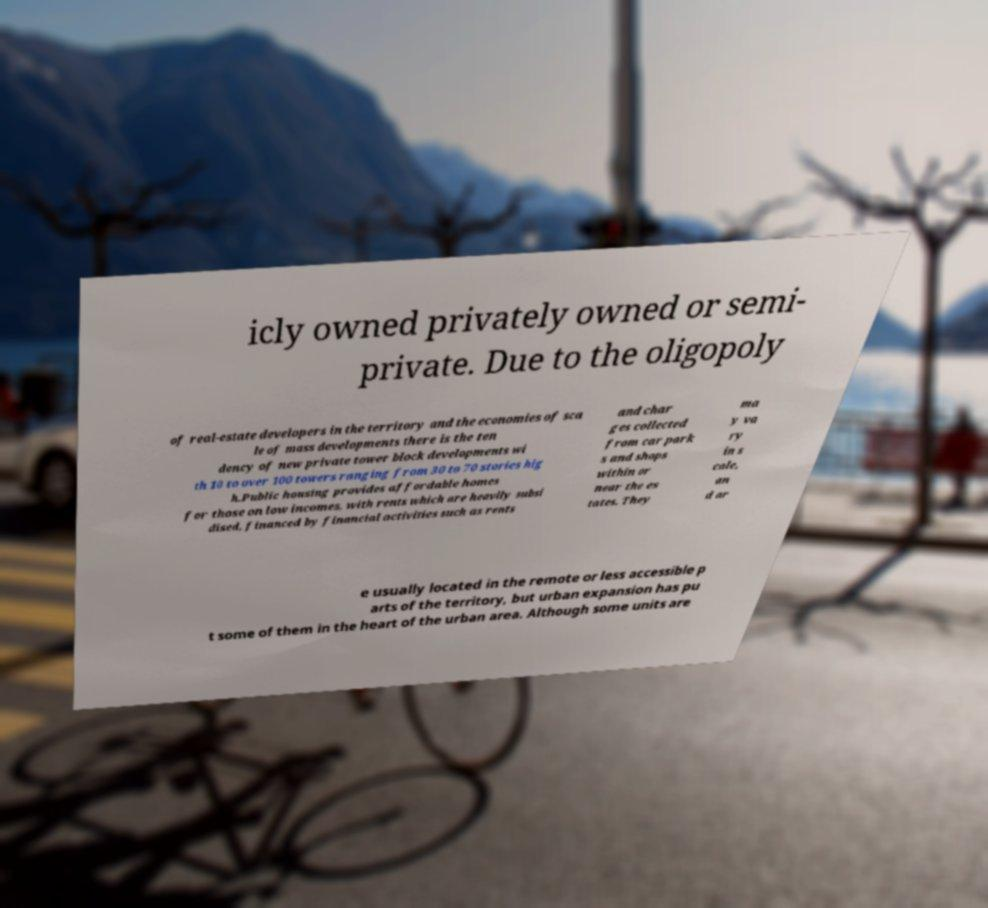Could you assist in decoding the text presented in this image and type it out clearly? icly owned privately owned or semi- private. Due to the oligopoly of real-estate developers in the territory and the economies of sca le of mass developments there is the ten dency of new private tower block developments wi th 10 to over 100 towers ranging from 30 to 70 stories hig h.Public housing provides affordable homes for those on low incomes, with rents which are heavily subsi dised, financed by financial activities such as rents and char ges collected from car park s and shops within or near the es tates. They ma y va ry in s cale, an d ar e usually located in the remote or less accessible p arts of the territory, but urban expansion has pu t some of them in the heart of the urban area. Although some units are 